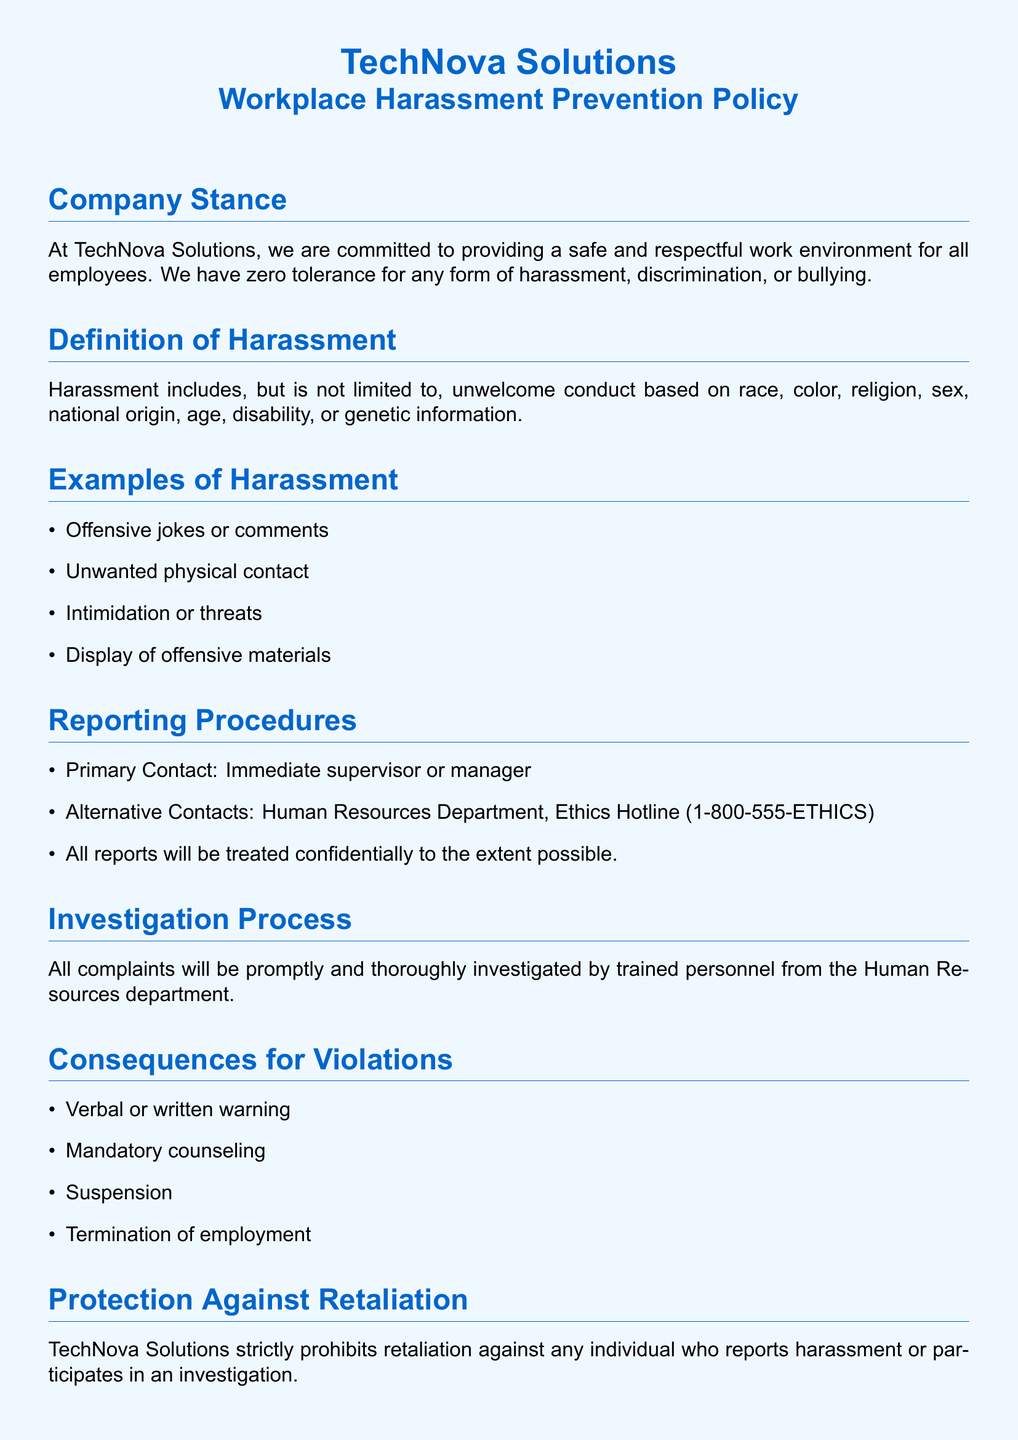What is the company stance on harassment? The company stance is a commitment to providing a safe and respectful work environment with zero tolerance for any form of harassment, discrimination, or bullying.
Answer: zero tolerance Who can be a primary contact for reporting harassment? The primary contact for reporting harassment is specified as the immediate supervisor or manager.
Answer: immediate supervisor What should an employee do if they experience harassment? An employee experiencing harassment should report it to their immediate supervisor or manager or use alternative contacts like Human Resources.
Answer: report it What is one example of harassment listed in the document? The document provides examples of harassment, including offensive jokes or comments, which illustrates unwelcome behavior.
Answer: offensive jokes What protection is offered against retaliation? The policy clearly states that TechNova Solutions prohibits retaliation against any individual who reports harassment or participates in an investigation.
Answer: prohibits retaliation What are the possible consequences for policy violations? The document outlines several consequences for violations of the harassment policy, varying from warnings to termination of employment.
Answer: termination of employment How often must employees complete harassment prevention training? The requirement for training is stated in the document, indicating that employees must complete this training annually.
Answer: annually What is the contact number for the Ethics Hotline? The Ethics Hotline number provided in the document is a point of contact for reporting concerns, which is clearly listed.
Answer: 1-800-555-ETHICS How often will the policy be reviewed? The policy review process is described, indicating that the workplace harassment prevention policy is to be reviewed annually.
Answer: annually 